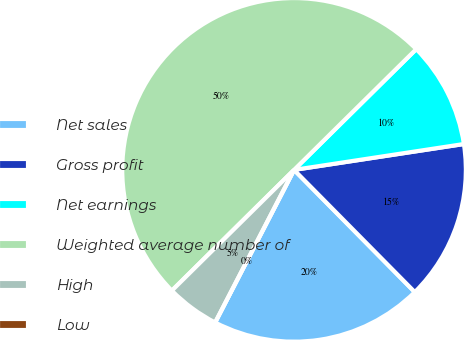<chart> <loc_0><loc_0><loc_500><loc_500><pie_chart><fcel>Net sales<fcel>Gross profit<fcel>Net earnings<fcel>Weighted average number of<fcel>High<fcel>Low<nl><fcel>20.0%<fcel>15.0%<fcel>10.0%<fcel>50.0%<fcel>5.0%<fcel>0.0%<nl></chart> 